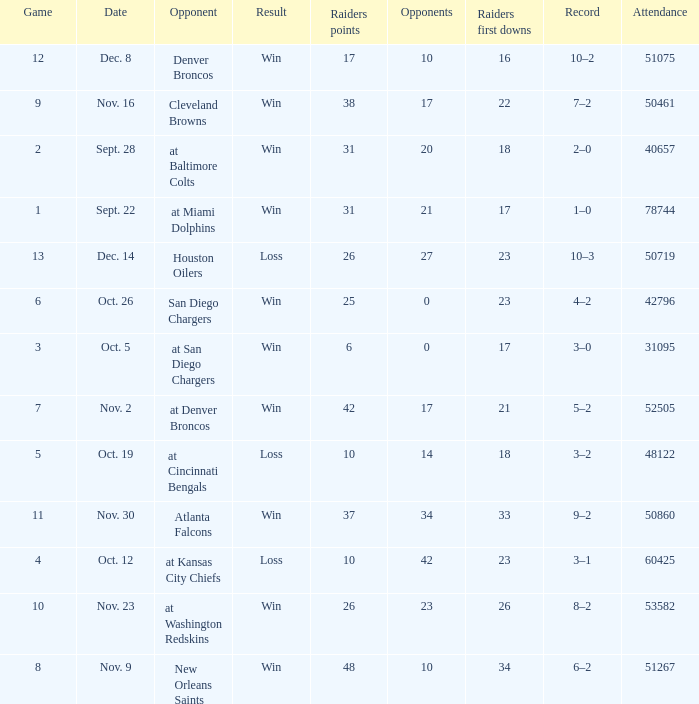Who was the game attended by 60425 people played against? At kansas city chiefs. 